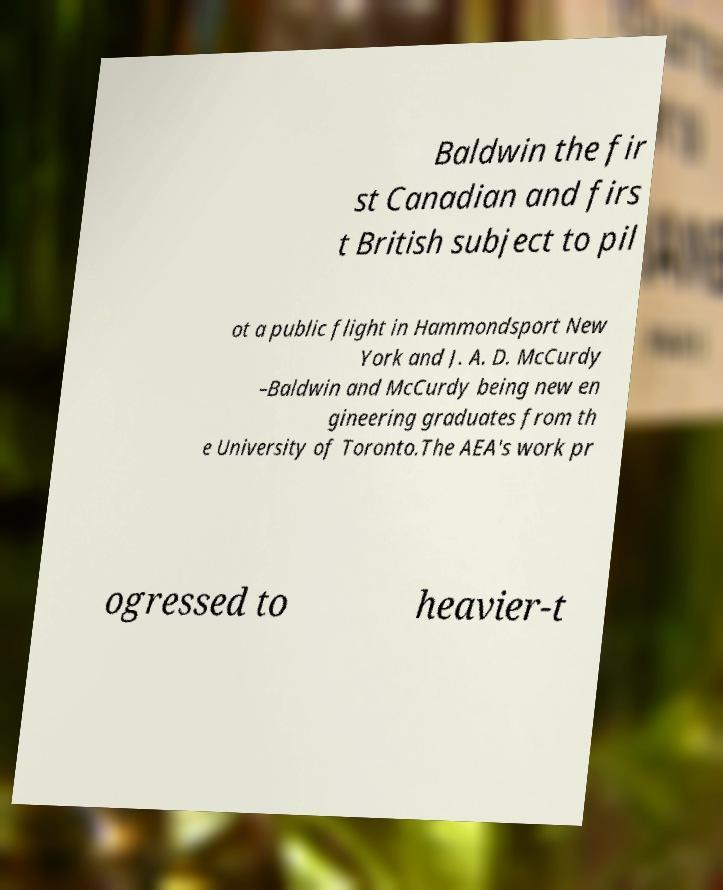There's text embedded in this image that I need extracted. Can you transcribe it verbatim? Baldwin the fir st Canadian and firs t British subject to pil ot a public flight in Hammondsport New York and J. A. D. McCurdy –Baldwin and McCurdy being new en gineering graduates from th e University of Toronto.The AEA's work pr ogressed to heavier-t 